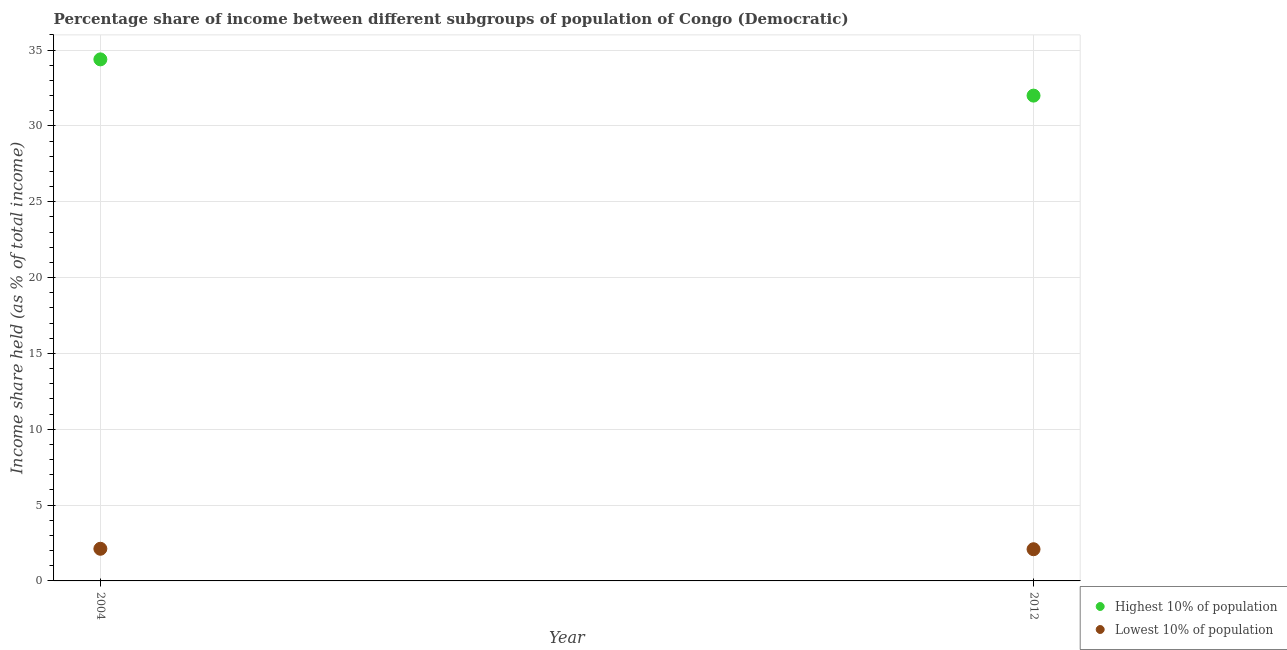What is the income share held by lowest 10% of the population in 2012?
Make the answer very short. 2.09. Across all years, what is the maximum income share held by highest 10% of the population?
Ensure brevity in your answer.  34.39. Across all years, what is the minimum income share held by lowest 10% of the population?
Give a very brief answer. 2.09. What is the total income share held by lowest 10% of the population in the graph?
Your answer should be very brief. 4.21. What is the difference between the income share held by highest 10% of the population in 2004 and that in 2012?
Your answer should be very brief. 2.39. What is the difference between the income share held by lowest 10% of the population in 2012 and the income share held by highest 10% of the population in 2004?
Your response must be concise. -32.3. What is the average income share held by lowest 10% of the population per year?
Your answer should be very brief. 2.1. In the year 2012, what is the difference between the income share held by lowest 10% of the population and income share held by highest 10% of the population?
Make the answer very short. -29.91. In how many years, is the income share held by lowest 10% of the population greater than 19 %?
Make the answer very short. 0. What is the ratio of the income share held by lowest 10% of the population in 2004 to that in 2012?
Your answer should be compact. 1.01. Is the income share held by highest 10% of the population in 2004 less than that in 2012?
Provide a short and direct response. No. In how many years, is the income share held by lowest 10% of the population greater than the average income share held by lowest 10% of the population taken over all years?
Offer a very short reply. 1. Does the income share held by lowest 10% of the population monotonically increase over the years?
Keep it short and to the point. No. Is the income share held by highest 10% of the population strictly less than the income share held by lowest 10% of the population over the years?
Provide a succinct answer. No. How many years are there in the graph?
Your response must be concise. 2. Does the graph contain any zero values?
Give a very brief answer. No. Where does the legend appear in the graph?
Offer a very short reply. Bottom right. How many legend labels are there?
Provide a short and direct response. 2. What is the title of the graph?
Your answer should be compact. Percentage share of income between different subgroups of population of Congo (Democratic). Does "Constant 2005 US$" appear as one of the legend labels in the graph?
Give a very brief answer. No. What is the label or title of the Y-axis?
Give a very brief answer. Income share held (as % of total income). What is the Income share held (as % of total income) of Highest 10% of population in 2004?
Ensure brevity in your answer.  34.39. What is the Income share held (as % of total income) in Lowest 10% of population in 2004?
Ensure brevity in your answer.  2.12. What is the Income share held (as % of total income) of Lowest 10% of population in 2012?
Offer a very short reply. 2.09. Across all years, what is the maximum Income share held (as % of total income) in Highest 10% of population?
Provide a succinct answer. 34.39. Across all years, what is the maximum Income share held (as % of total income) of Lowest 10% of population?
Give a very brief answer. 2.12. Across all years, what is the minimum Income share held (as % of total income) of Lowest 10% of population?
Offer a very short reply. 2.09. What is the total Income share held (as % of total income) of Highest 10% of population in the graph?
Your answer should be compact. 66.39. What is the total Income share held (as % of total income) in Lowest 10% of population in the graph?
Make the answer very short. 4.21. What is the difference between the Income share held (as % of total income) in Highest 10% of population in 2004 and that in 2012?
Ensure brevity in your answer.  2.39. What is the difference between the Income share held (as % of total income) in Lowest 10% of population in 2004 and that in 2012?
Give a very brief answer. 0.03. What is the difference between the Income share held (as % of total income) of Highest 10% of population in 2004 and the Income share held (as % of total income) of Lowest 10% of population in 2012?
Offer a terse response. 32.3. What is the average Income share held (as % of total income) in Highest 10% of population per year?
Offer a very short reply. 33.2. What is the average Income share held (as % of total income) of Lowest 10% of population per year?
Your answer should be compact. 2.1. In the year 2004, what is the difference between the Income share held (as % of total income) in Highest 10% of population and Income share held (as % of total income) in Lowest 10% of population?
Your response must be concise. 32.27. In the year 2012, what is the difference between the Income share held (as % of total income) in Highest 10% of population and Income share held (as % of total income) in Lowest 10% of population?
Offer a terse response. 29.91. What is the ratio of the Income share held (as % of total income) in Highest 10% of population in 2004 to that in 2012?
Keep it short and to the point. 1.07. What is the ratio of the Income share held (as % of total income) in Lowest 10% of population in 2004 to that in 2012?
Your response must be concise. 1.01. What is the difference between the highest and the second highest Income share held (as % of total income) in Highest 10% of population?
Provide a succinct answer. 2.39. What is the difference between the highest and the second highest Income share held (as % of total income) in Lowest 10% of population?
Give a very brief answer. 0.03. What is the difference between the highest and the lowest Income share held (as % of total income) in Highest 10% of population?
Ensure brevity in your answer.  2.39. 